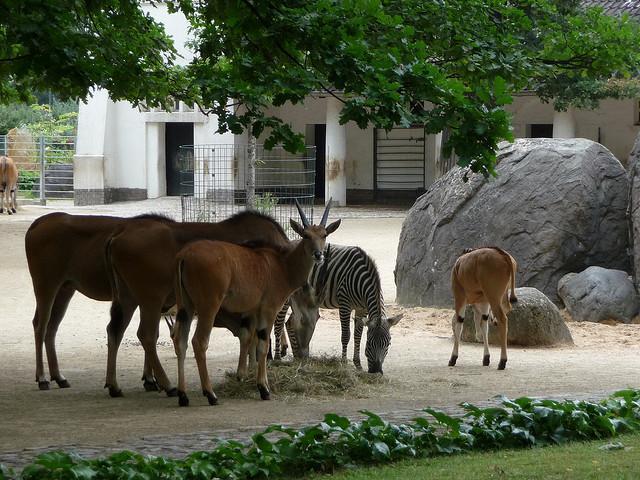How many people have blue uniforms?
Give a very brief answer. 0. 